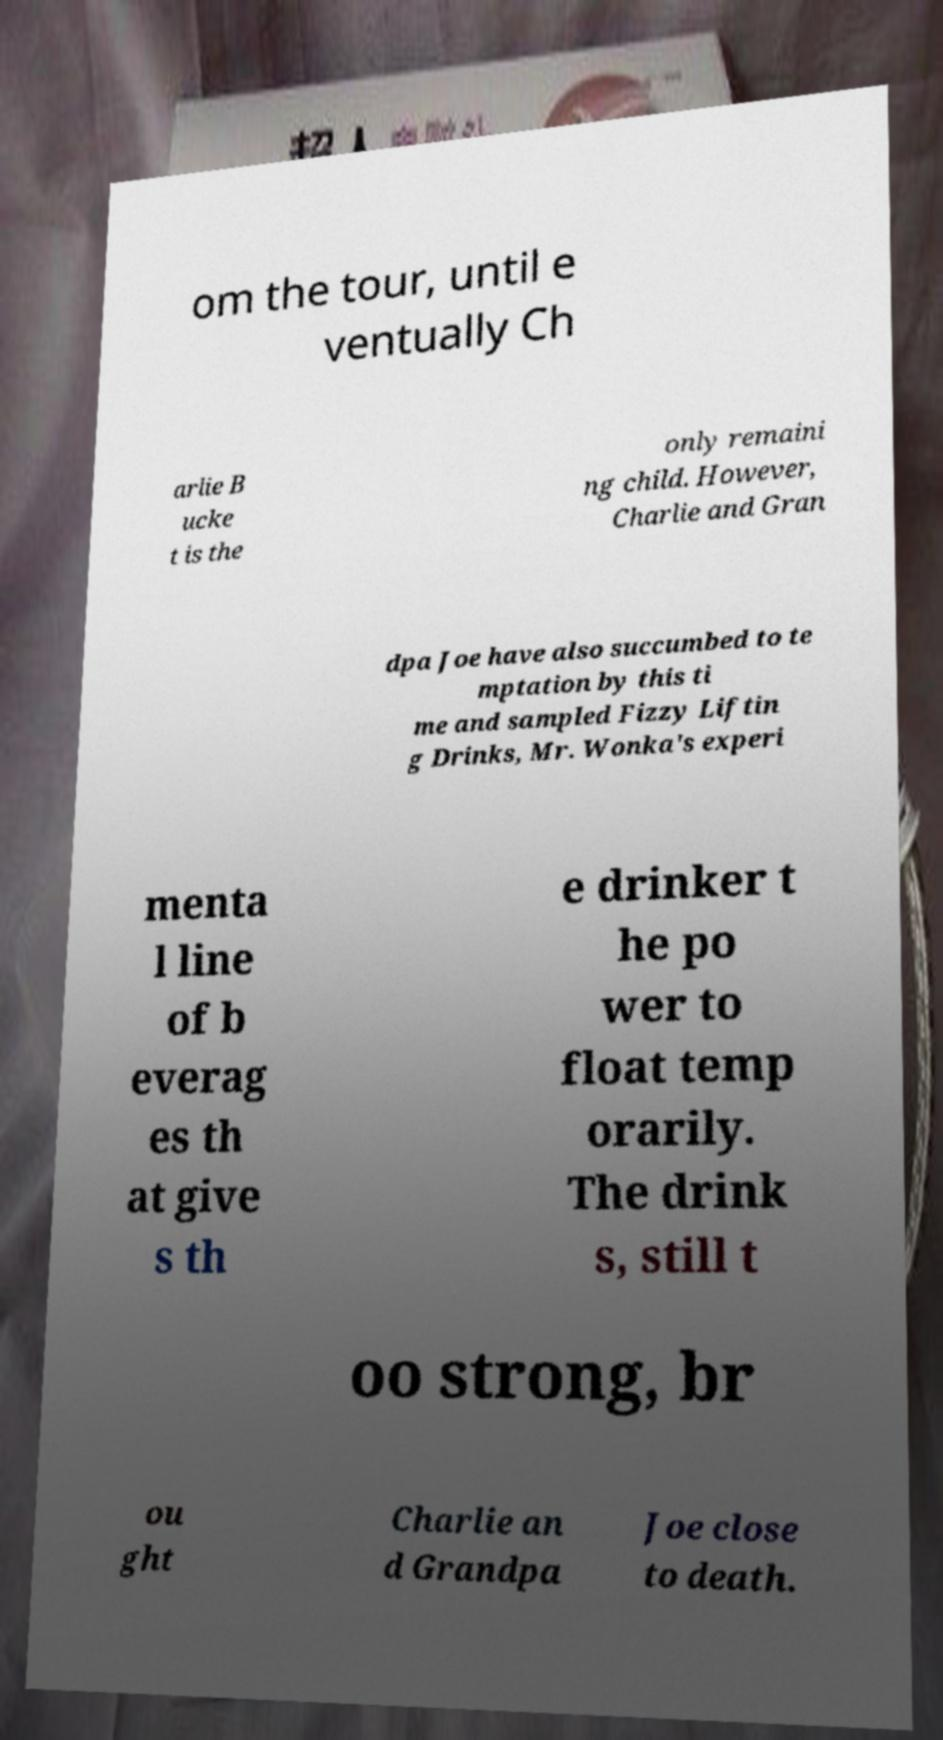Could you extract and type out the text from this image? om the tour, until e ventually Ch arlie B ucke t is the only remaini ng child. However, Charlie and Gran dpa Joe have also succumbed to te mptation by this ti me and sampled Fizzy Liftin g Drinks, Mr. Wonka's experi menta l line of b everag es th at give s th e drinker t he po wer to float temp orarily. The drink s, still t oo strong, br ou ght Charlie an d Grandpa Joe close to death. 